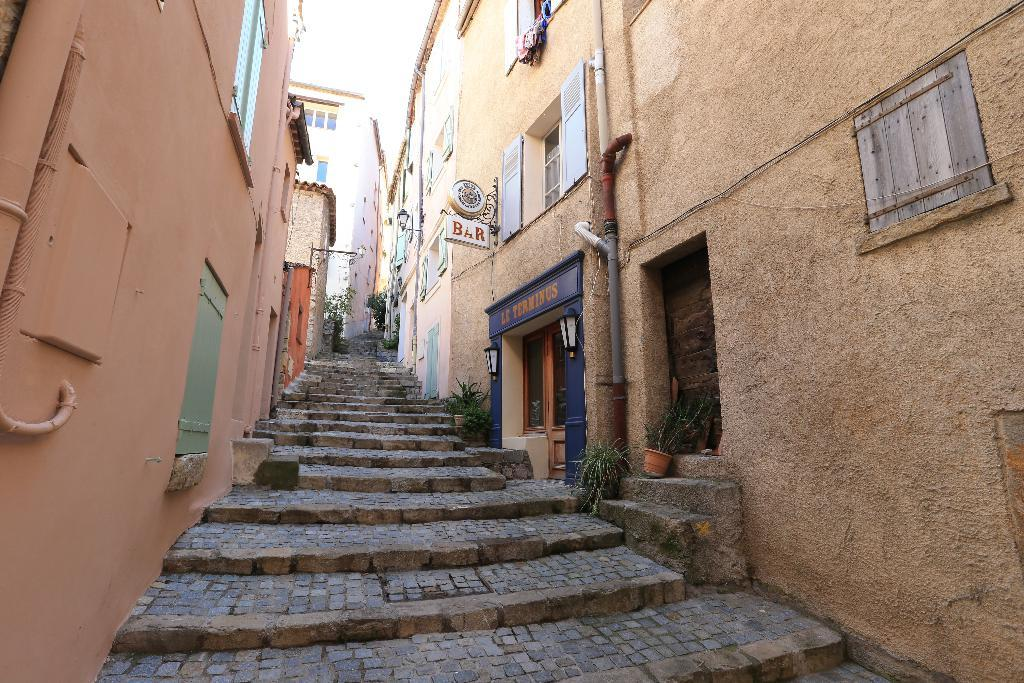What is located between the buildings in the image? There are stairs between the buildings in the image. What can be seen on the buildings in the image? There are windows on the buildings in the image. What type of infrastructure is visible in the image? Pipes are visible in the image. What is present on the right side of the picture? On the right side of the picture, there are boards, lights, and pots with plants. What is the fact that the pocket is used for in the image? There is no pocket present in the image, so it cannot be used for any purpose. What is the purpose of the plants in the image? The purpose of the plants in the image is not explicitly stated, but they are likely present for aesthetic or environmental reasons. 